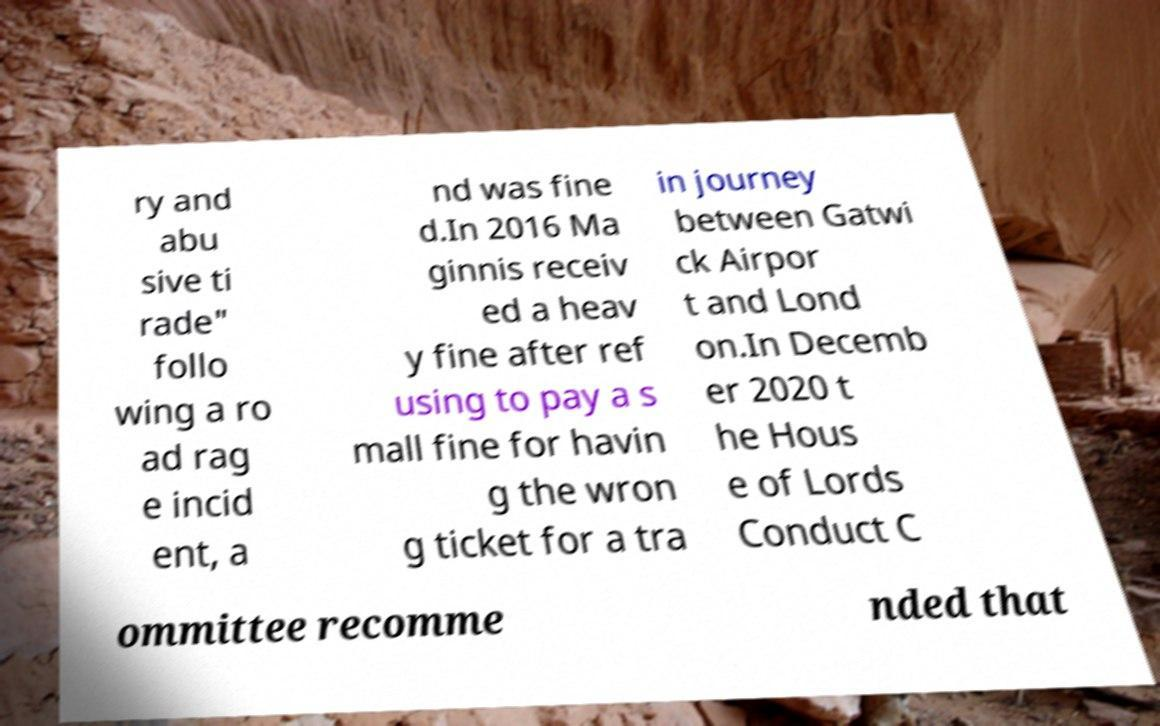I need the written content from this picture converted into text. Can you do that? ry and abu sive ti rade" follo wing a ro ad rag e incid ent, a nd was fine d.In 2016 Ma ginnis receiv ed a heav y fine after ref using to pay a s mall fine for havin g the wron g ticket for a tra in journey between Gatwi ck Airpor t and Lond on.In Decemb er 2020 t he Hous e of Lords Conduct C ommittee recomme nded that 